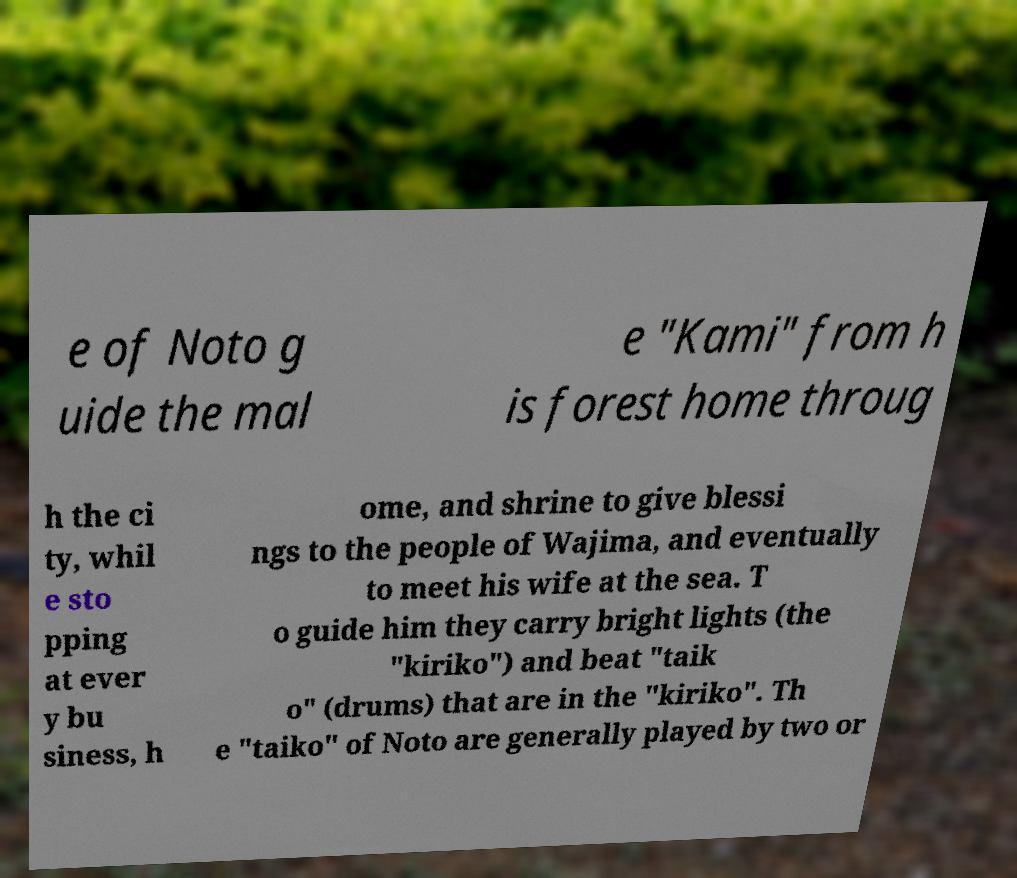For documentation purposes, I need the text within this image transcribed. Could you provide that? e of Noto g uide the mal e "Kami" from h is forest home throug h the ci ty, whil e sto pping at ever y bu siness, h ome, and shrine to give blessi ngs to the people of Wajima, and eventually to meet his wife at the sea. T o guide him they carry bright lights (the "kiriko") and beat "taik o" (drums) that are in the "kiriko". Th e "taiko" of Noto are generally played by two or 